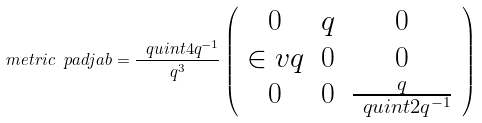Convert formula to latex. <formula><loc_0><loc_0><loc_500><loc_500>\ m e t r i c { \ p a d j } { a b } = \frac { \ q u i n t { 4 } { q ^ { - 1 } } } { q ^ { 3 } } \left ( \begin{array} { c c c } 0 & q & 0 \\ \in v { q } & 0 & 0 \\ 0 & 0 & \frac { q } { \ q u i n t { 2 } { q ^ { - 1 } } } \end{array} \right )</formula> 